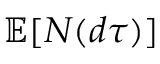<formula> <loc_0><loc_0><loc_500><loc_500>\mathbb { E } [ N ( d \tau ) ]</formula> 